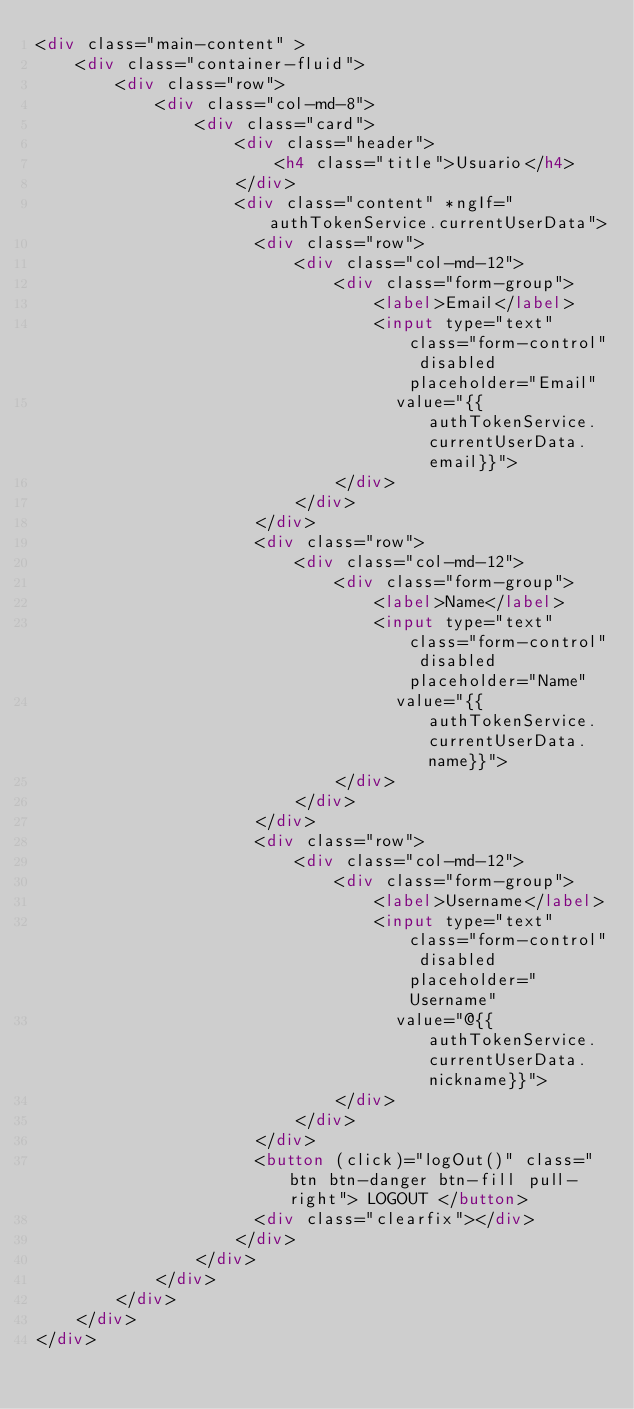<code> <loc_0><loc_0><loc_500><loc_500><_HTML_><div class="main-content" >
    <div class="container-fluid">
        <div class="row">
            <div class="col-md-8">
                <div class="card">
                    <div class="header">
                        <h4 class="title">Usuario</h4>
                    </div>
                    <div class="content" *ngIf="authTokenService.currentUserData">
                      <div class="row">
                          <div class="col-md-12">
                              <div class="form-group">
                                  <label>Email</label>
                                  <input type="text" class="form-control" disabled placeholder="Email"
                                    value="{{authTokenService.currentUserData.email}}">
                              </div>
                          </div>
                      </div>
                      <div class="row">
                          <div class="col-md-12">
                              <div class="form-group">
                                  <label>Name</label>
                                  <input type="text" class="form-control" disabled placeholder="Name"
                                    value="{{authTokenService.currentUserData.name}}">
                              </div>
                          </div>
                      </div>
                      <div class="row">
                          <div class="col-md-12">
                              <div class="form-group">
                                  <label>Username</label>
                                  <input type="text" class="form-control" disabled placeholder="Username"
                                    value="@{{authTokenService.currentUserData.nickname}}">
                              </div>
                          </div>
                      </div>
                      <button (click)="logOut()" class="btn btn-danger btn-fill pull-right"> LOGOUT </button>
                      <div class="clearfix"></div>
                    </div>
                </div>
            </div>
        </div>
    </div>
</div>
</code> 